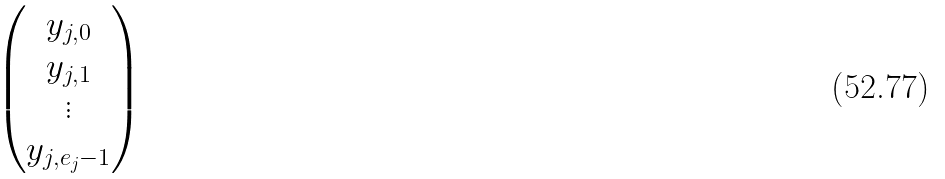Convert formula to latex. <formula><loc_0><loc_0><loc_500><loc_500>\begin{pmatrix} y _ { j , 0 } \\ y _ { j , 1 } \\ \vdots \\ y _ { j , e _ { j } - 1 } \end{pmatrix}</formula> 